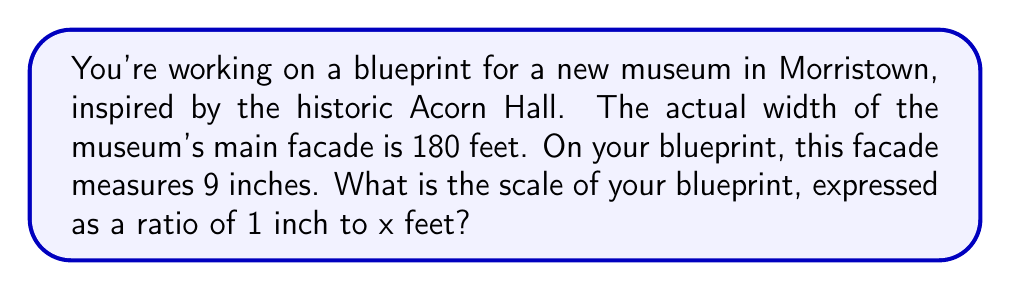Teach me how to tackle this problem. Let's approach this step-by-step:

1) We know that 9 inches on the blueprint represents 180 feet in reality.

2) We need to find out how many feet 1 inch represents.

3) We can set up a proportion:
   
   $\frac{9 \text{ inches}}{180 \text{ feet}} = \frac{1 \text{ inch}}{x \text{ feet}}$

4) Cross multiply:
   
   $9x = 180 \cdot 1$

5) Solve for x:
   
   $x = \frac{180}{9} = 20$

6) Therefore, 1 inch on the blueprint represents 20 feet in reality.

7) The scale is expressed as a ratio of 1 inch to x feet, which is 1:20.
Answer: 1:20 